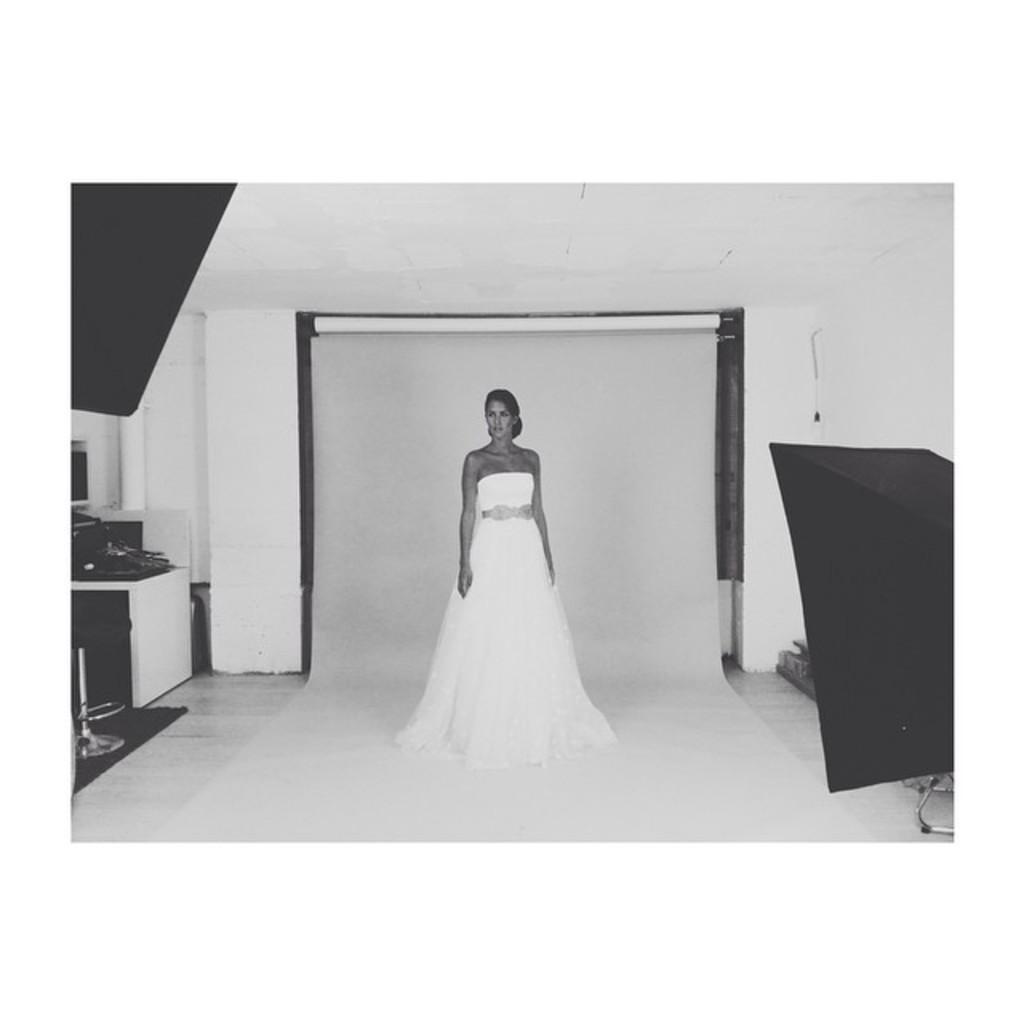Can you describe this image briefly? In the picture we can see a black and white photograph of a woman standing in the white dress and giving a pose to the camera and beside her we can see a table on it we can see some things are placed on it. 